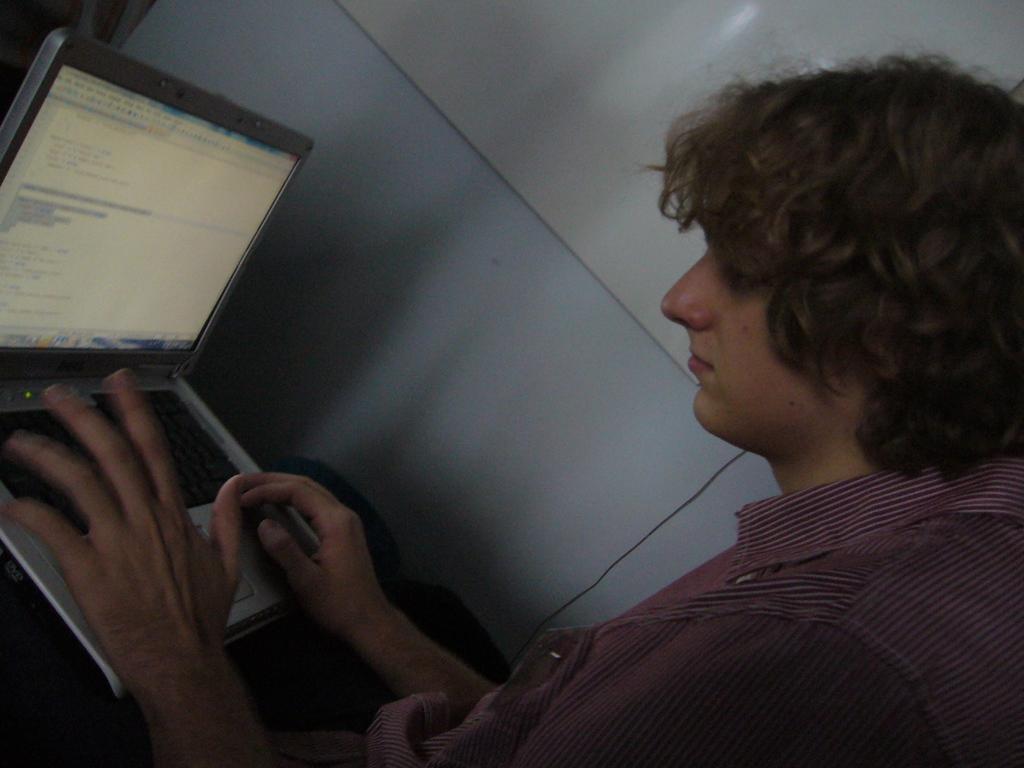Can you describe this image briefly? In this picture there is a boy wearing pink color shirt, sitting on the chair and working on the laptop. Behind there is a white color wall. 